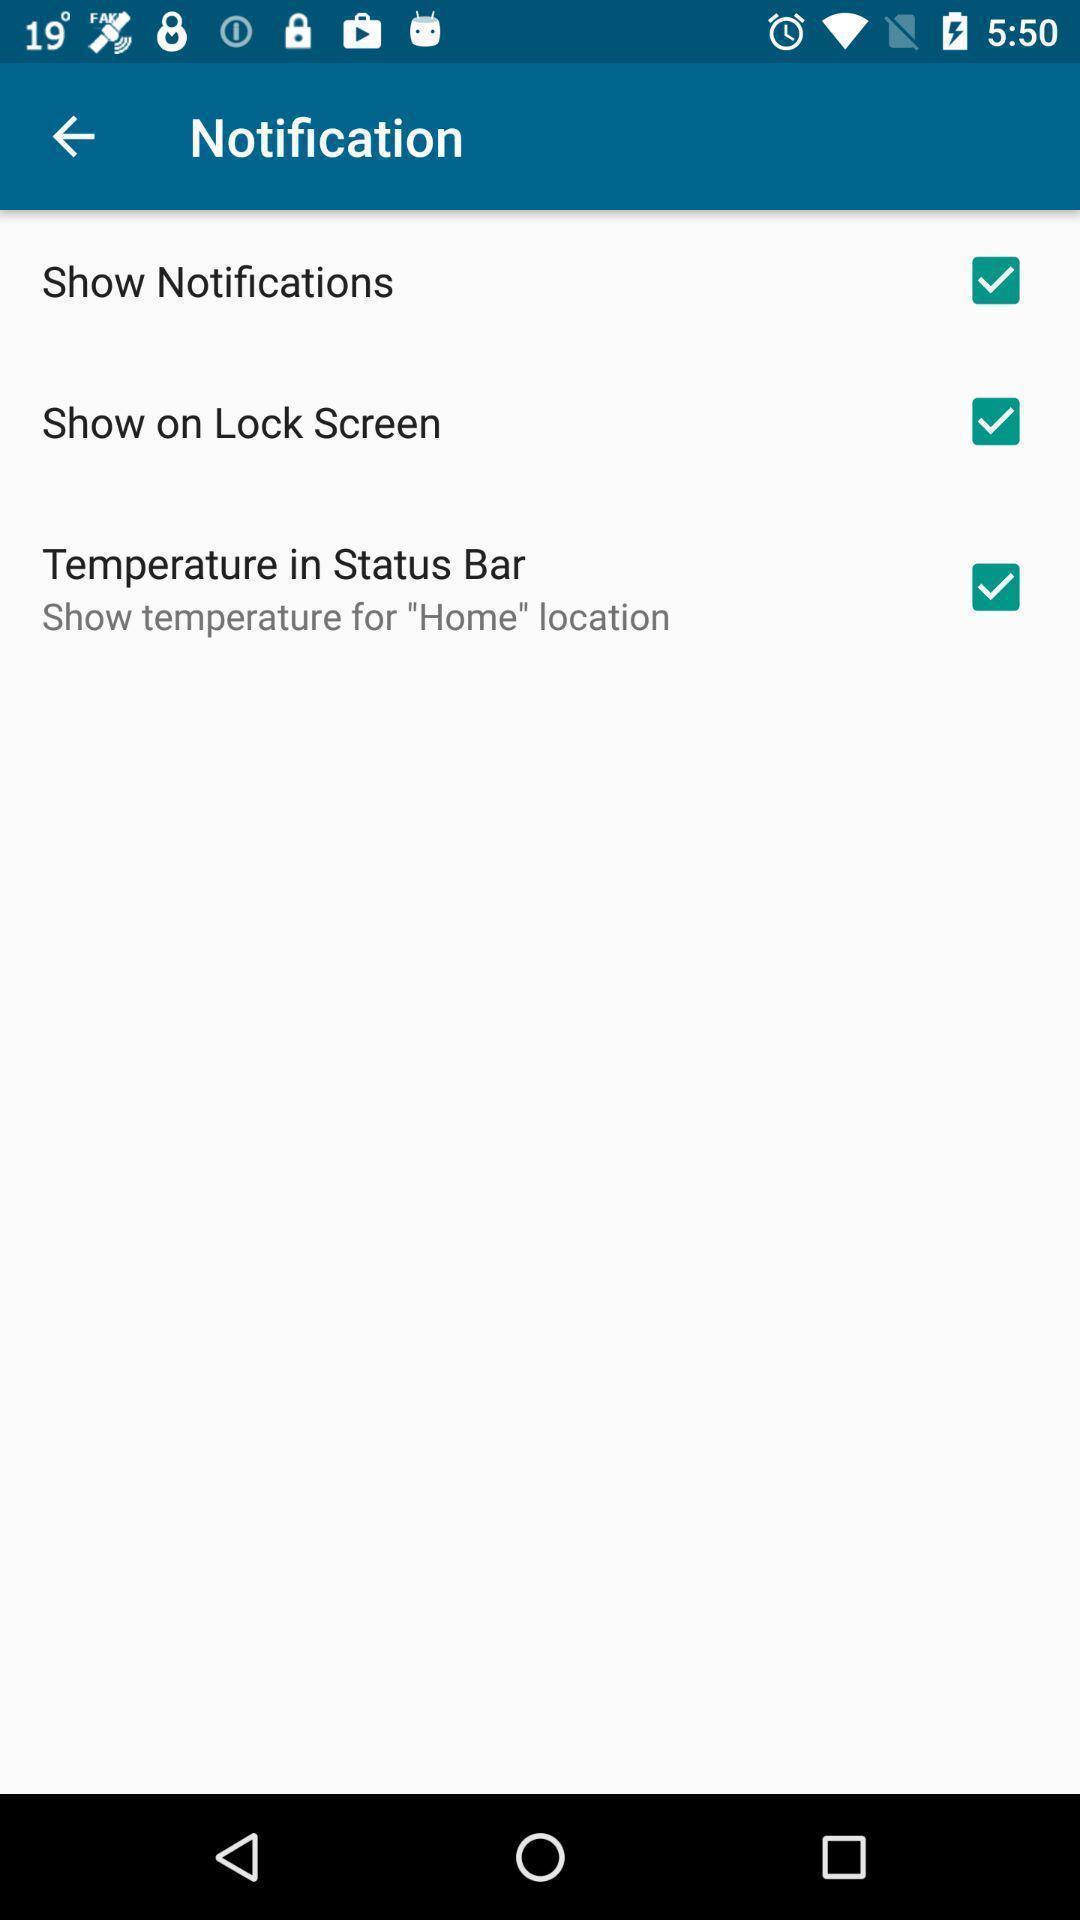Describe the content in this image. Screen showing notification options. 